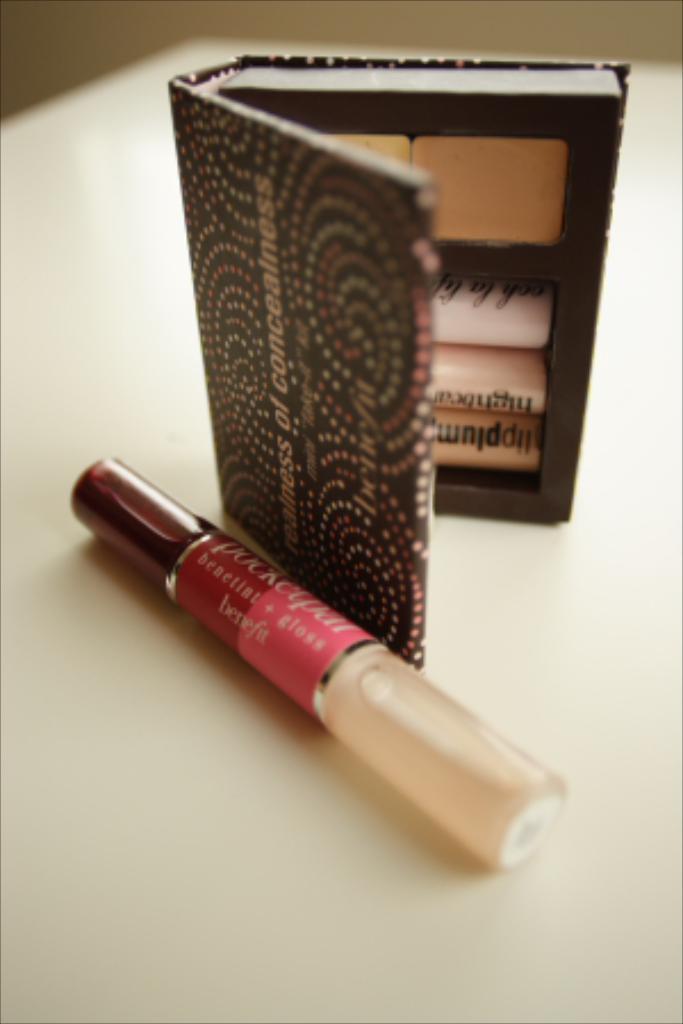Can you describe this image briefly? At the bottom of the image there is a table with an eye shadow kit and a lip gloss bottle on it. In the background there is a wall. 